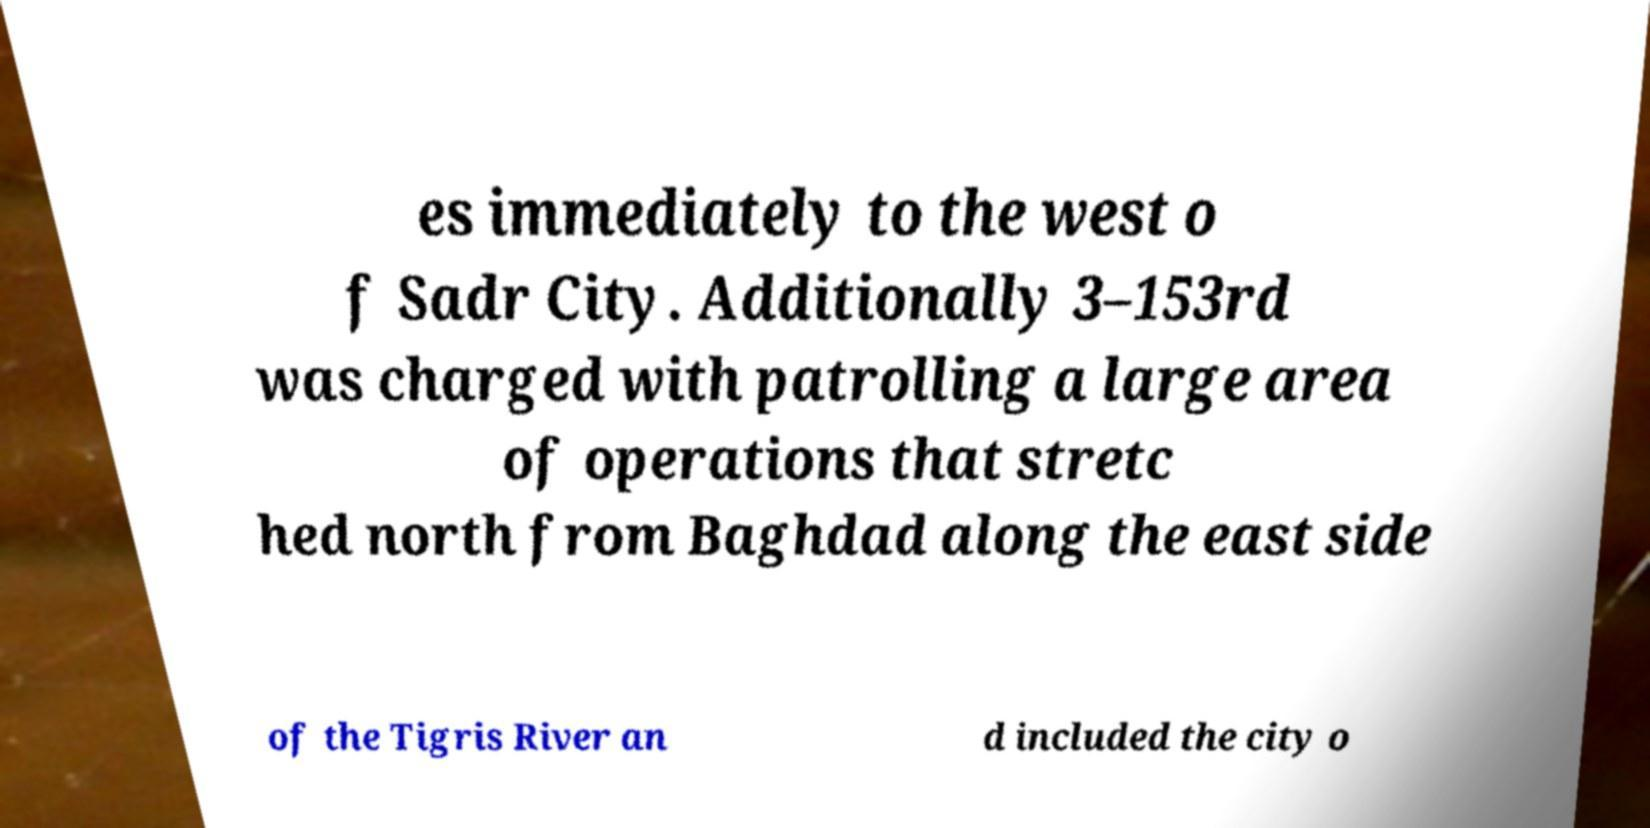Please identify and transcribe the text found in this image. es immediately to the west o f Sadr City. Additionally 3–153rd was charged with patrolling a large area of operations that stretc hed north from Baghdad along the east side of the Tigris River an d included the city o 